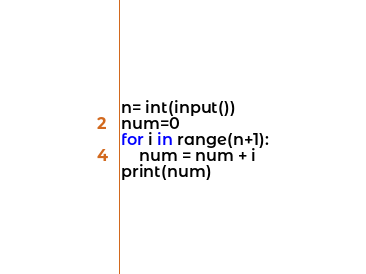Convert code to text. <code><loc_0><loc_0><loc_500><loc_500><_Python_>n= int(input())
num=0
for i in range(n+1):
	num = num + i
print(num)</code> 